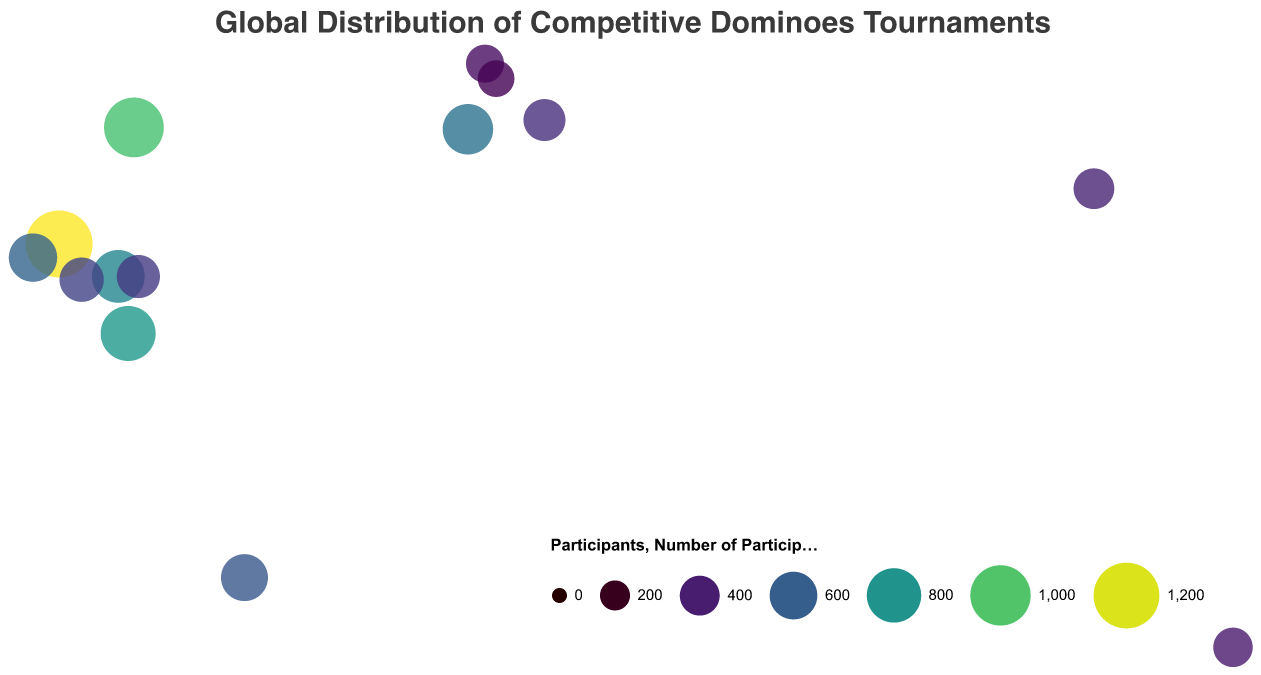What is the title of the figure? The title of the figure is usually displayed at the top of the plot. Here, it reads "Global Distribution of Competitive Dominoes Tournaments".
Answer: Global Distribution of Competitive Dominoes Tournaments Which country has the tournament with the most participants? By observing the size and tooltips of the circles, the largest circle with the highest number of participants is in Cuba, indicating the "Havana Domino Masters" with 1250 participants.
Answer: Cuba Compare the number of participants in the "World Series of Domino" tournament in the USA to the "European Domino Open" in Spain. Which has more participants? By looking at the tooltip data provided by the circles for the USA and Spain, the "World Series of Domino" in the USA has 980 participants while the "European Domino Open" in Spain has 680 participants. Thus, the USA tournament has more participants.
Answer: USA What is the smallest number of participants in any tournament on this plot? The tooltip information for the smallest circles can be used to identify the tournament with the smallest number of participants, which is the "Paris Domino Challenge" in France with 330 participants.
Answer: 330 How many countries are represented in the plot? Each circle represents a unique country. By counting the unique entries in the "Country" field, there are 14 countries represented.
Answer: 14 Which tournament is held in Australia and how many participants does it have? By locating the circle near the coordinates of Australia and checking its tooltip, we find that the "Sydney Domino Open" is held in Australia with 390 participants.
Answer: Sydney Domino Open, 390 participants What is the total number of participants across all tournaments shown in the plot? Sum the "Participants" field values for all tournaments: 1250 + 980 + 820 + 750 + 680 + 620 + 580 + 510 + 480 + 450 + 420 + 390 + 360 + 330. The total is 8620.
Answer: 8620 Identify the tournament held in Shanghai, China, and its number of participants. By checking the circle near China's coordinates and referring to its tooltip, we see that the "Shanghai Domino Masters" is held in Shanghai with 420 participants.
Answer: Shanghai Domino Masters, 420 participants Which regions (by latitude) host the most competitive domino tournaments? By inspecting the latitude values and the number of circles clustered in certain latitude ranges, it can be observed that the highest concentration of tournaments occurs around the latitudes 10° to 40°.
Answer: 10° to 40° 